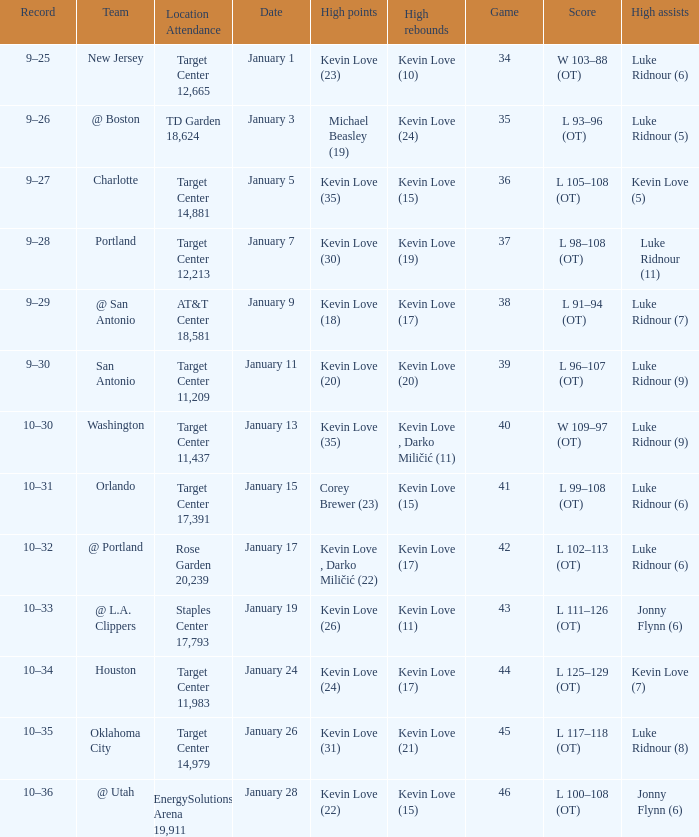Who had the high points when the team was charlotte? Kevin Love (35). 